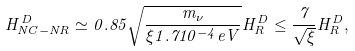<formula> <loc_0><loc_0><loc_500><loc_500>H _ { N C - N R } ^ { D } \simeq 0 . 8 5 \sqrt { \frac { m _ { \nu } } { \xi 1 . 7 1 0 ^ { - 4 } e V } } H _ { R } ^ { D } \leq \frac { 7 } { \sqrt { \xi } } H _ { R } ^ { D } ,</formula> 